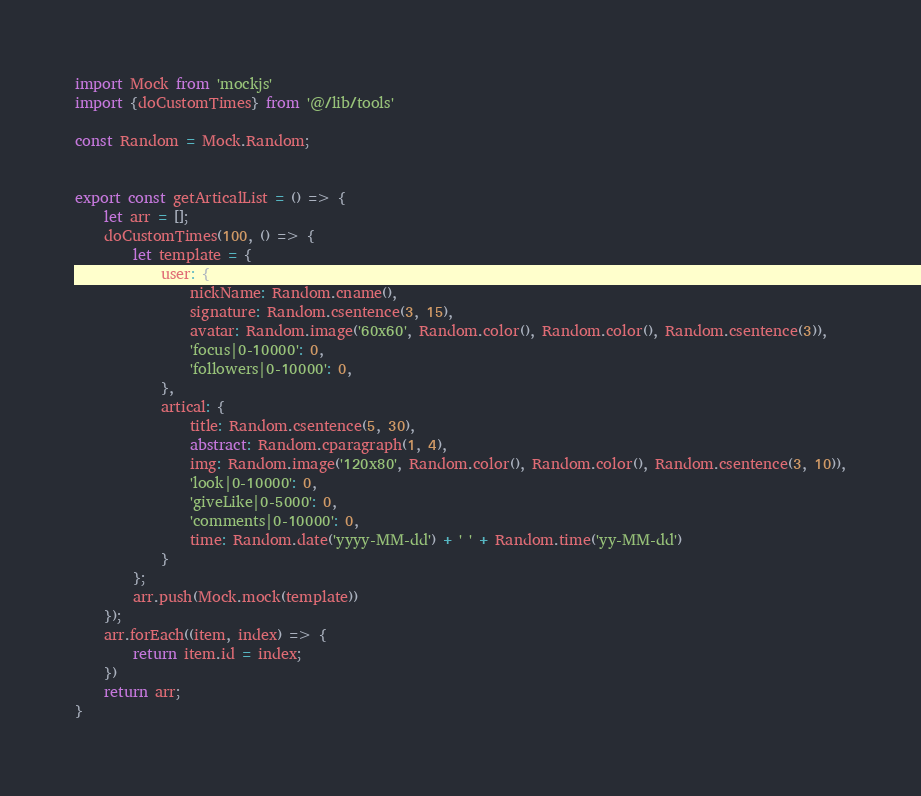Convert code to text. <code><loc_0><loc_0><loc_500><loc_500><_JavaScript_>import Mock from 'mockjs'
import {doCustomTimes} from '@/lib/tools'

const Random = Mock.Random;


export const getArticalList = () => {
    let arr = [];
    doCustomTimes(100, () => {
        let template = {
            user: {
                nickName: Random.cname(),
                signature: Random.csentence(3, 15),
                avatar: Random.image('60x60', Random.color(), Random.color(), Random.csentence(3)),
                'focus|0-10000': 0,
                'followers|0-10000': 0,
            },
            artical: {
                title: Random.csentence(5, 30),
                abstract: Random.cparagraph(1, 4),
                img: Random.image('120x80', Random.color(), Random.color(), Random.csentence(3, 10)),
                'look|0-10000': 0,
                'giveLike|0-5000': 0,
                'comments|0-10000': 0,
                time: Random.date('yyyy-MM-dd') + ' ' + Random.time('yy-MM-dd')
            }
        };
        arr.push(Mock.mock(template))
    });
    arr.forEach((item, index) => {
        return item.id = index;
    })
    return arr;
}</code> 